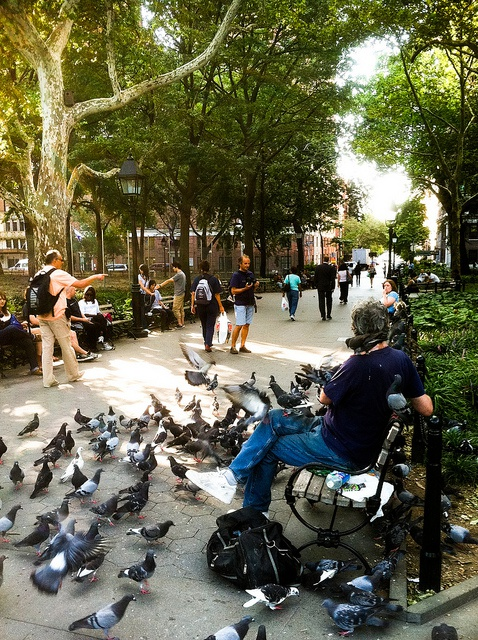Describe the objects in this image and their specific colors. I can see bird in black, gray, darkgray, and white tones, people in black, navy, white, and blue tones, bench in black, gray, white, and darkgray tones, handbag in black, gray, darkgray, and purple tones, and people in black, tan, and white tones in this image. 